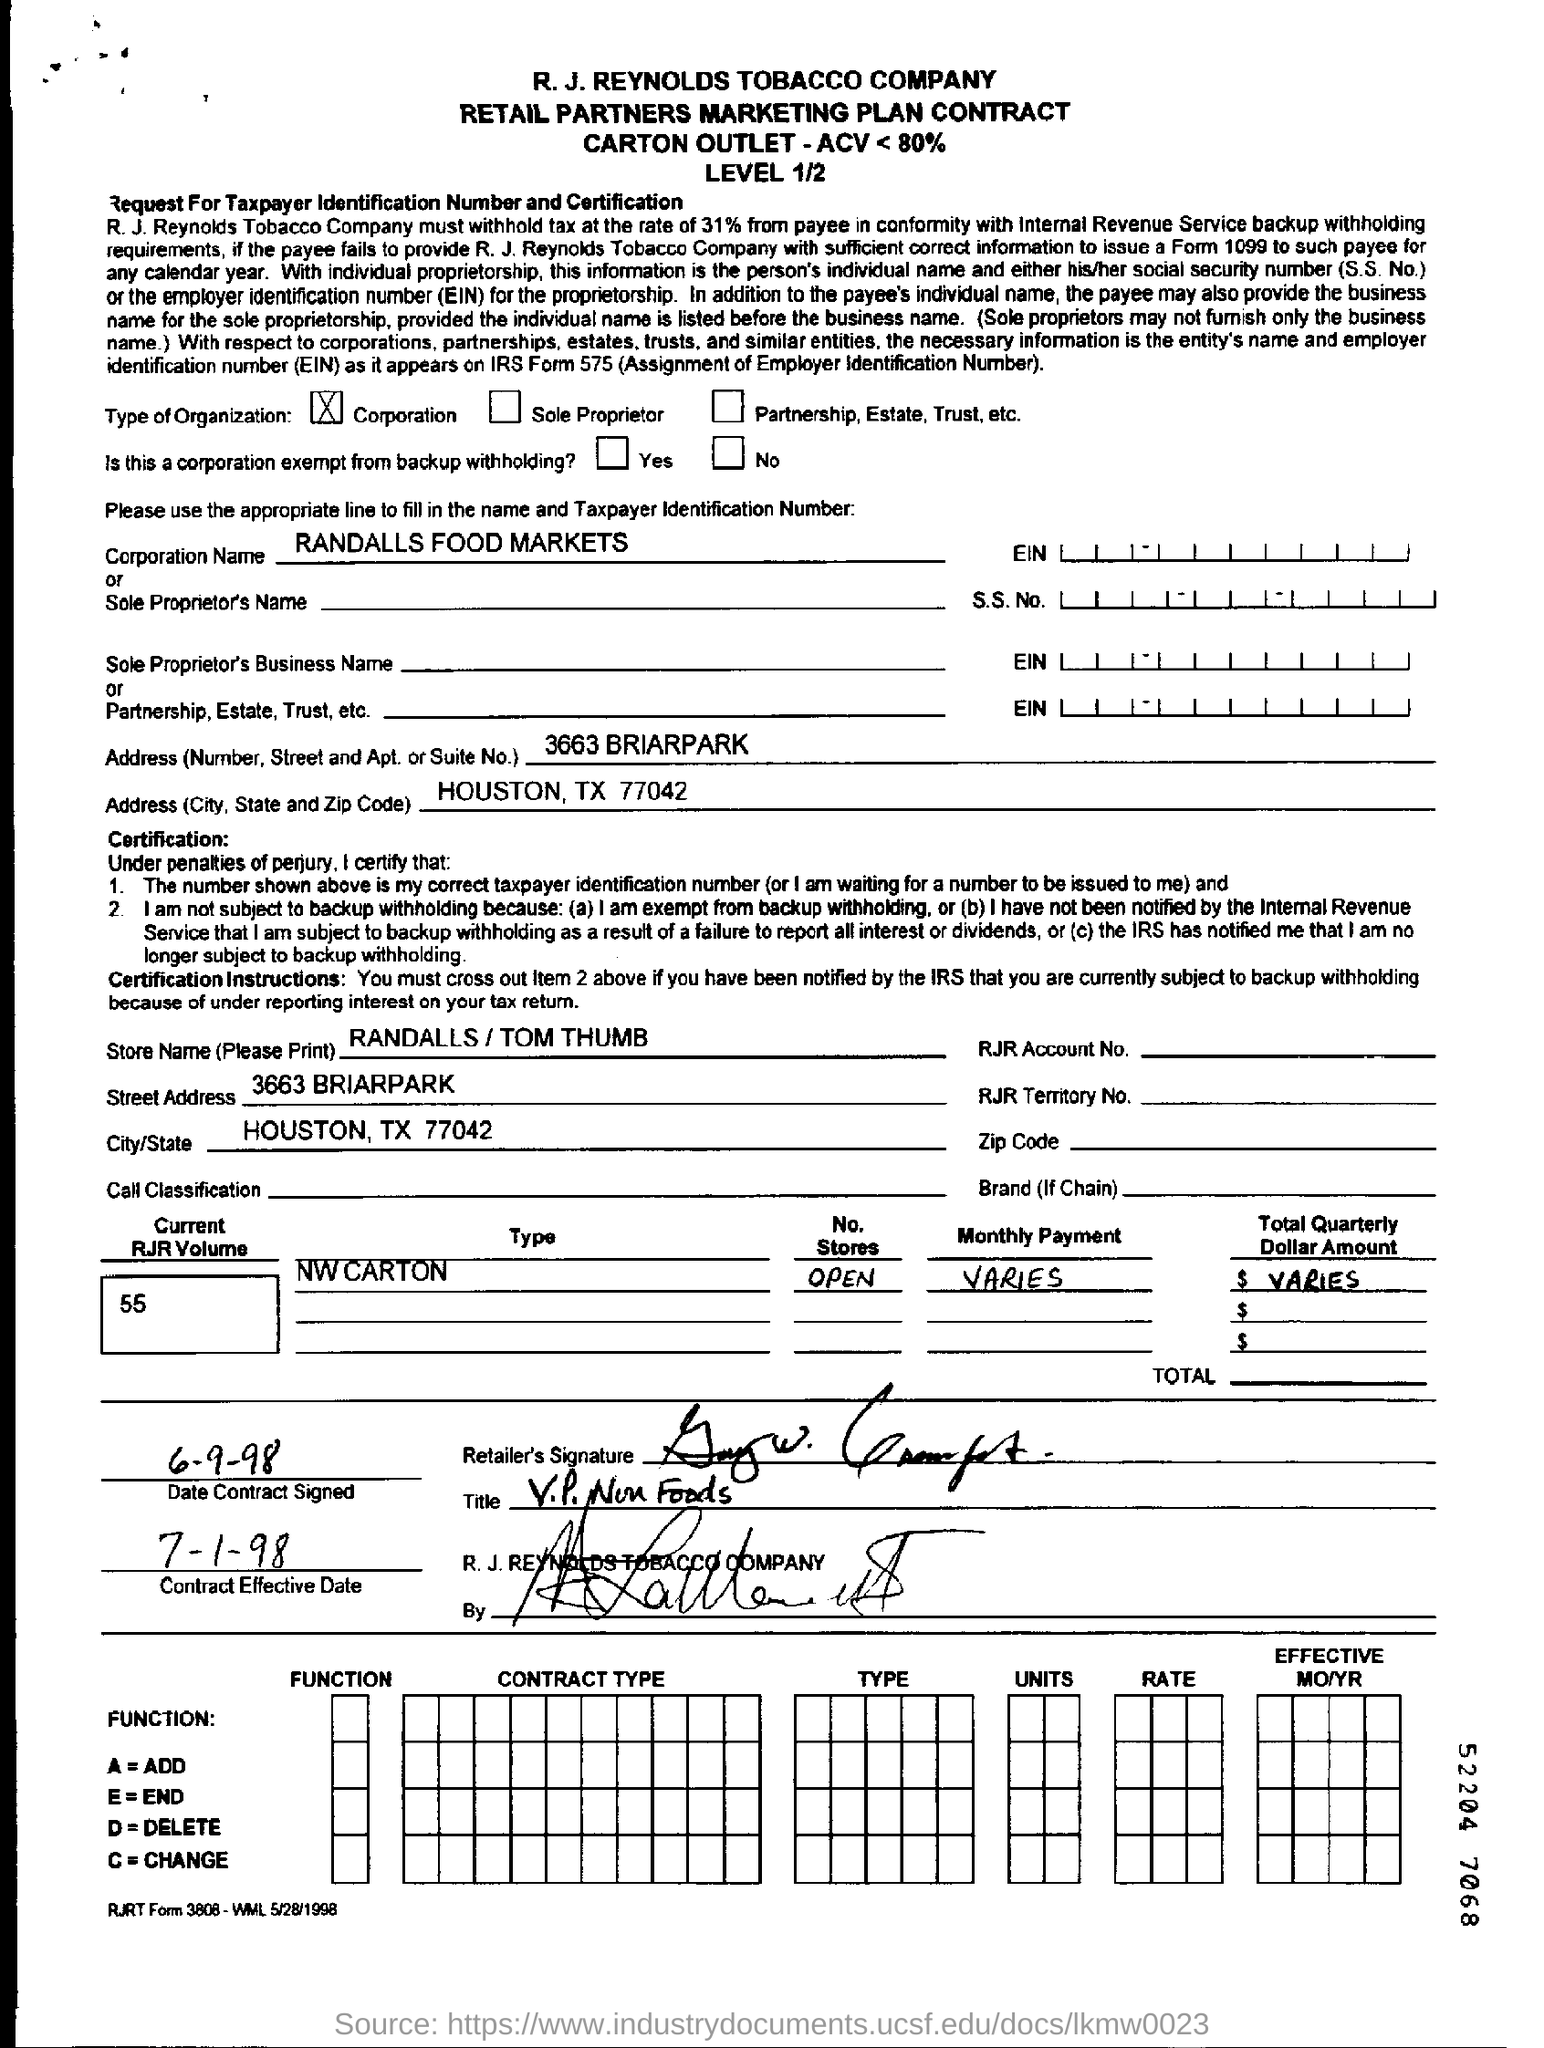What is the name of the corporation?
Your answer should be very brief. RANDALLS FOOD MARKETS. What is the Corporation Name ?
Provide a succinct answer. RANDALLS FOOD MARKETS. What is the Contract signed Date ?
Your response must be concise. 6-9-98. What is the Contract Effective Date?
Your answer should be compact. 7-1-98. What is the current RJR volume ?
Offer a very short reply. 55. In which city is the Randalls Food Markets Corporation ?
Offer a very short reply. HOUSTON, TX 77042. 